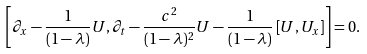<formula> <loc_0><loc_0><loc_500><loc_500>\left [ \partial _ { x } - \frac { 1 } { ( 1 - \lambda ) } U , \partial _ { t } - \frac { c ^ { 2 } } { ( 1 - \lambda ) ^ { 2 } } U - \frac { 1 } { ( 1 - \lambda ) } \left [ U , U _ { x } \right ] \right ] = 0 .</formula> 